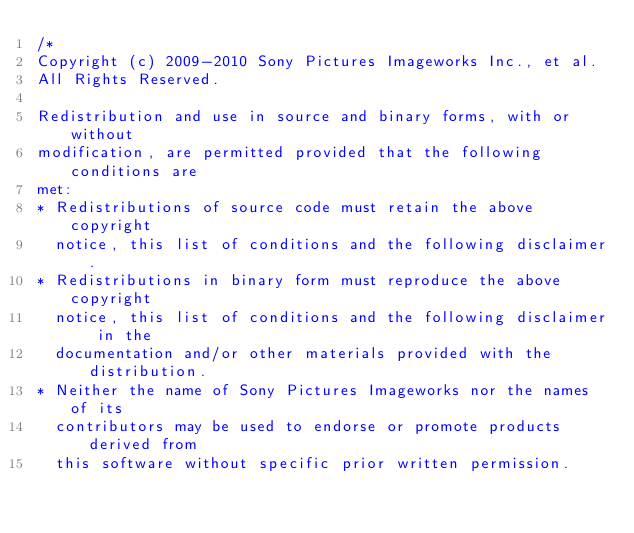<code> <loc_0><loc_0><loc_500><loc_500><_C++_>/*
Copyright (c) 2009-2010 Sony Pictures Imageworks Inc., et al.
All Rights Reserved.

Redistribution and use in source and binary forms, with or without
modification, are permitted provided that the following conditions are
met:
* Redistributions of source code must retain the above copyright
  notice, this list of conditions and the following disclaimer.
* Redistributions in binary form must reproduce the above copyright
  notice, this list of conditions and the following disclaimer in the
  documentation and/or other materials provided with the distribution.
* Neither the name of Sony Pictures Imageworks nor the names of its
  contributors may be used to endorse or promote products derived from
  this software without specific prior written permission.</code> 